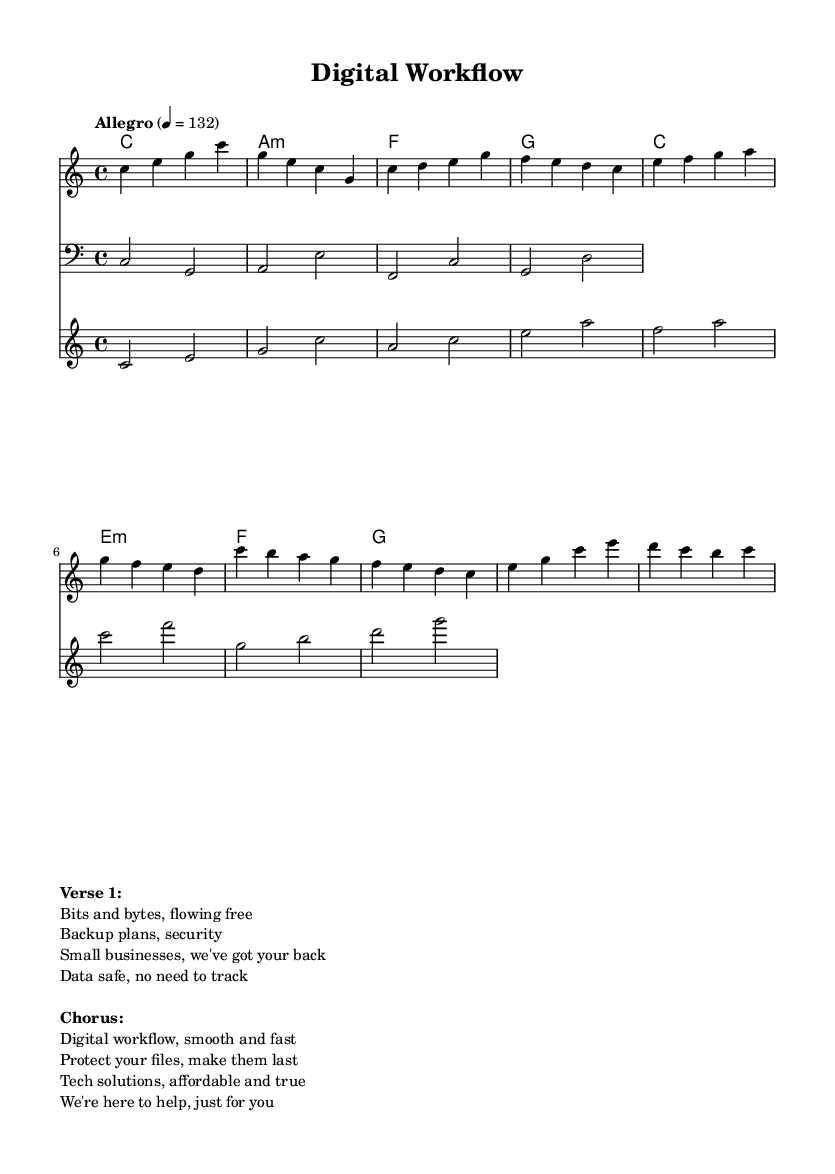What is the key signature of this music? The key signature is C major, which has no sharps or flats.
Answer: C major What is the time signature of this piece? The time signature is indicated after the key signature and is shown as 4/4, meaning there are four beats in a measure.
Answer: 4/4 What is the tempo marking for this music? The tempo marking indicates the speed of the piece, which is marked as Allegro at a metronome mark of 132 beats per minute.
Answer: Allegro, 132 How many measures are in the melody section? The melody section consists of four measures for the intro, four measures for the verse, and four measures for the chorus, totaling twelve measures.
Answer: 12 Which part plays the bass line? The bass line is specified as being in the clef that shows lower pitches, particularly written in the bass staff.
Answer: Bass What is the tonic chord in the chorus? The tonic chord refers to the first chord of the scale, which in this piece is indicated as the C major chord during the chorus section.
Answer: C major Identify a characteristic feature of the arpeggiator. The arpeggiator features a played sequence of the chord tones in ascending patterns, moving between the notes in each chord.
Answer: Ascending arpeggios 